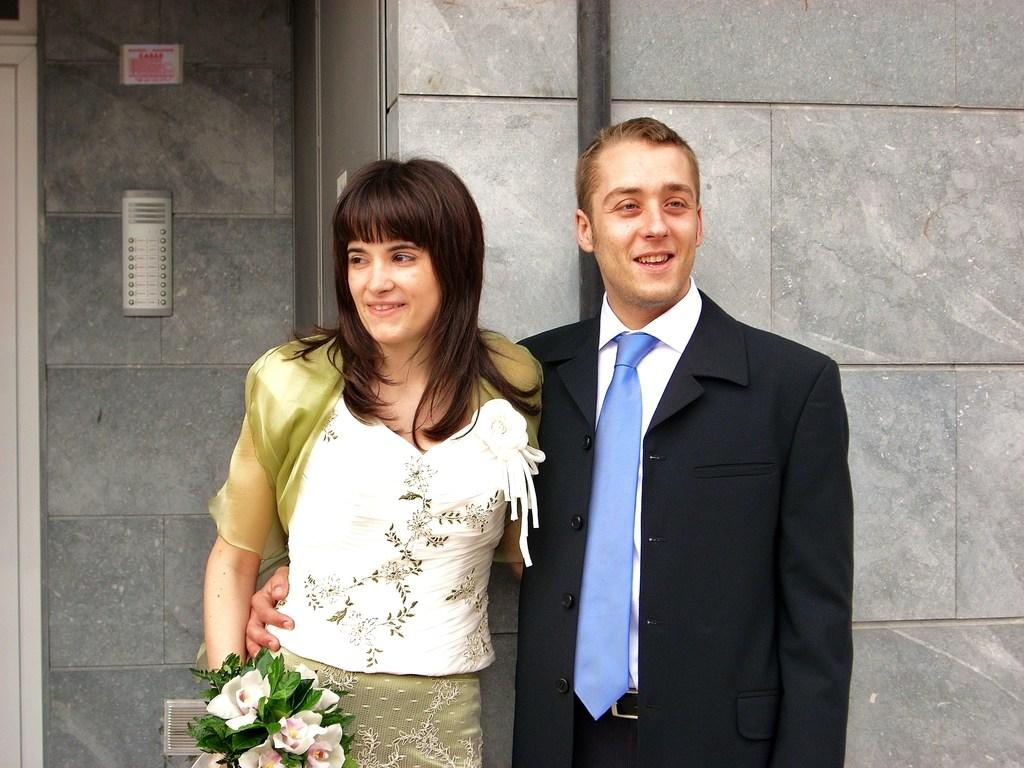Who is present in the image? There is a woman and a man in the image. What expressions do they have? Both the woman and the man are smiling. What can be seen at the bottom of the image? There is a flower bouquet at the bottom of the image. What architectural features are visible in the background? There is a wall, a rod, doors, and an unspecified object in the background of the image. What decorative item is present in the background? There is a poster in the background of the image. What type of zinc is present in the image? There is no zinc present in the image. Who is the writer in the image? There is no writer depicted in the image. 